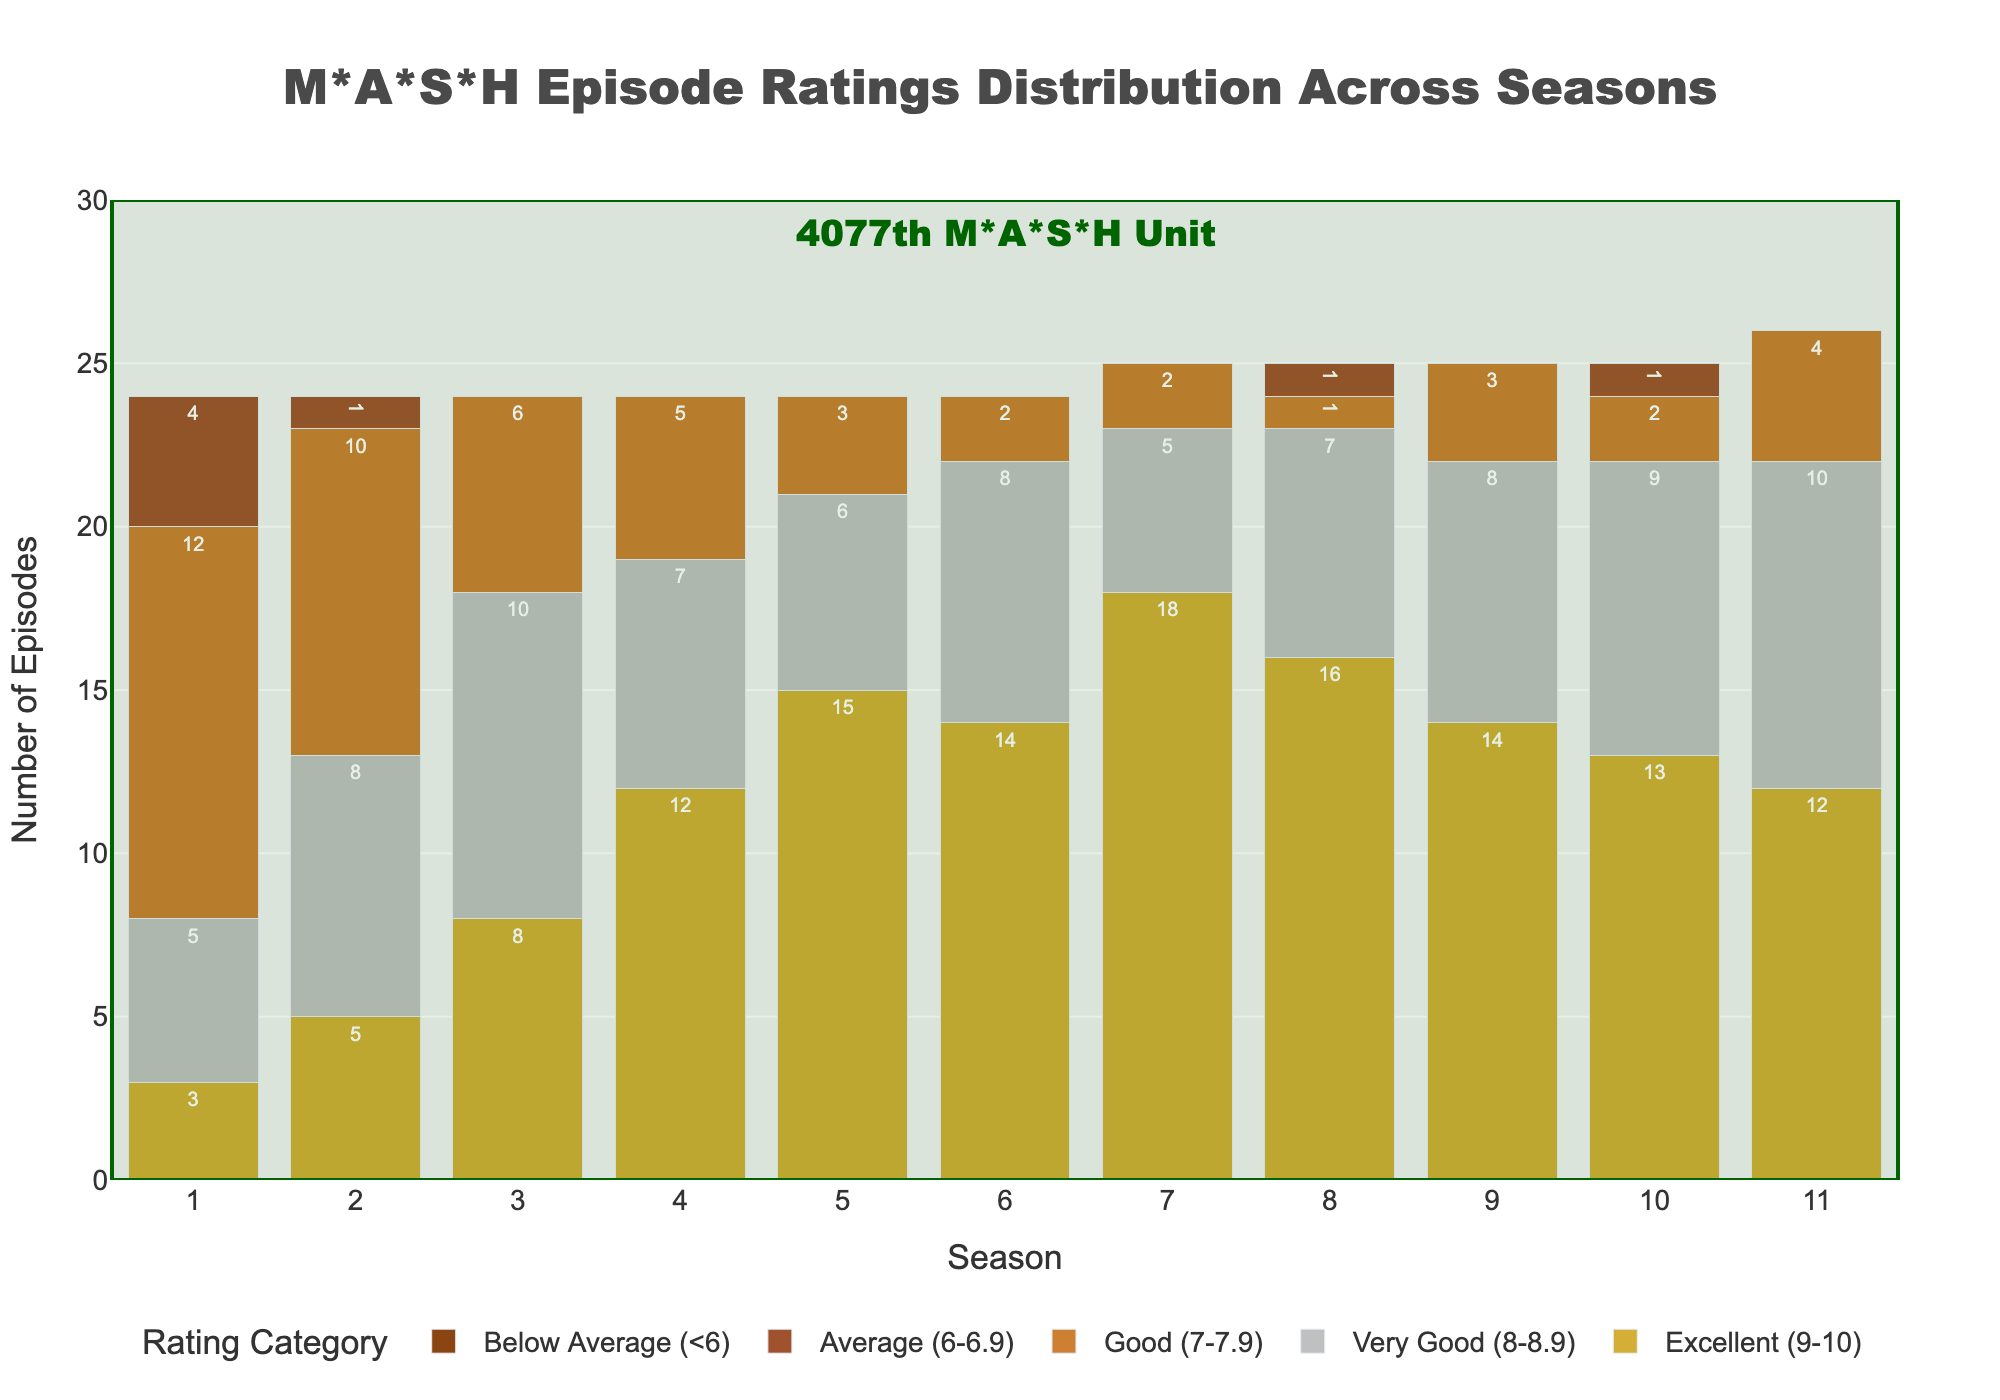Which season has the highest number of "Excellent (9-10)" rated episodes? To find this, look for the tallest bar in the "Excellent (9-10)" category. Season 7 has the highest with 18 episodes.
Answer: Season 7 Which season has the least number of "Good (7-7.9)" rated episodes? Identify the shortest bar in the "Good (7-7.9)" category. Season 8 has only 1 episode rated "Good (7-7.9)".
Answer: Season 8 How many total episodes are there in Season 1? Add the heights of all ratings categories for Season 1 to get the total number of episodes: 3 (Excellent) + 5 (Very Good) + 12 (Good) + 4 (Average) = 24.
Answer: 24 Which category has the most consistently high number of episodes across all seasons? Analyze the bars of each category across all seasons. "Excellent (9-10)" consistently shows higher bars across most seasons compared to other categories.
Answer: Excellent (9-10) Compare Season 4 and Season 6 based on the number of "Very Good (8-8.9)" rated episodes. Which season had more? Compare the bar heights for the "Very Good (8-8.9)" category for Season 4 and Season 6. Season 6 has 8 episodes, while Season 4 has 7 episodes.
Answer: Season 6 What is the sum of "Below Average (<6)" rated episodes across all seasons? Add the number of "Below Average (<6)" episodes for each season: 0 + 0 + 0 + 0 + 0 + 0 + 0 + 0 + 0 + 0 + 0 = 0.
Answer: 0 How many total episodes are rated "Average (6-6.9)" across all seasons? Sum up the "Average (6-6.9)" episodes from each season: 4 + 1 + 0 + 0 + 0 + 0 + 0 + 1 + 0 + 1 + 0 = 7.
Answer: 7 Which season has the highest total number of episodes? Add the number of episodes in all categories within each season and compare. Season 2 has the most episodes: 5 (Excellent) + 8 (Very Good) + 10 (Good) + 1 (Average) = 24.
Answer: Season 2 Which rating category has the most episodes in Season 5? Identify the tallest bar in Season 5. The "Excellent (9-10)" category has 15 episodes.
Answer: Excellent (9-10) Did any season have all its episodes rated "Good (7-7.9)" or better? Look for any season without bars in either "Average (6-6.9)" or "Below Average (<6)" categories. Seasons 3, 4, 5, 6, 7, 9, and 11 have no episodes rated below "Good (7-7.9)".
Answer: Yes 